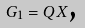Convert formula to latex. <formula><loc_0><loc_0><loc_500><loc_500>G _ { 1 } = Q X \text {,}</formula> 